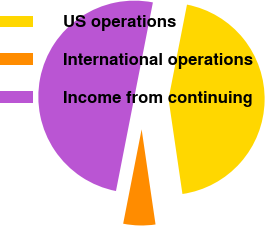Convert chart. <chart><loc_0><loc_0><loc_500><loc_500><pie_chart><fcel>US operations<fcel>International operations<fcel>Income from continuing<nl><fcel>44.61%<fcel>5.39%<fcel>50.0%<nl></chart> 